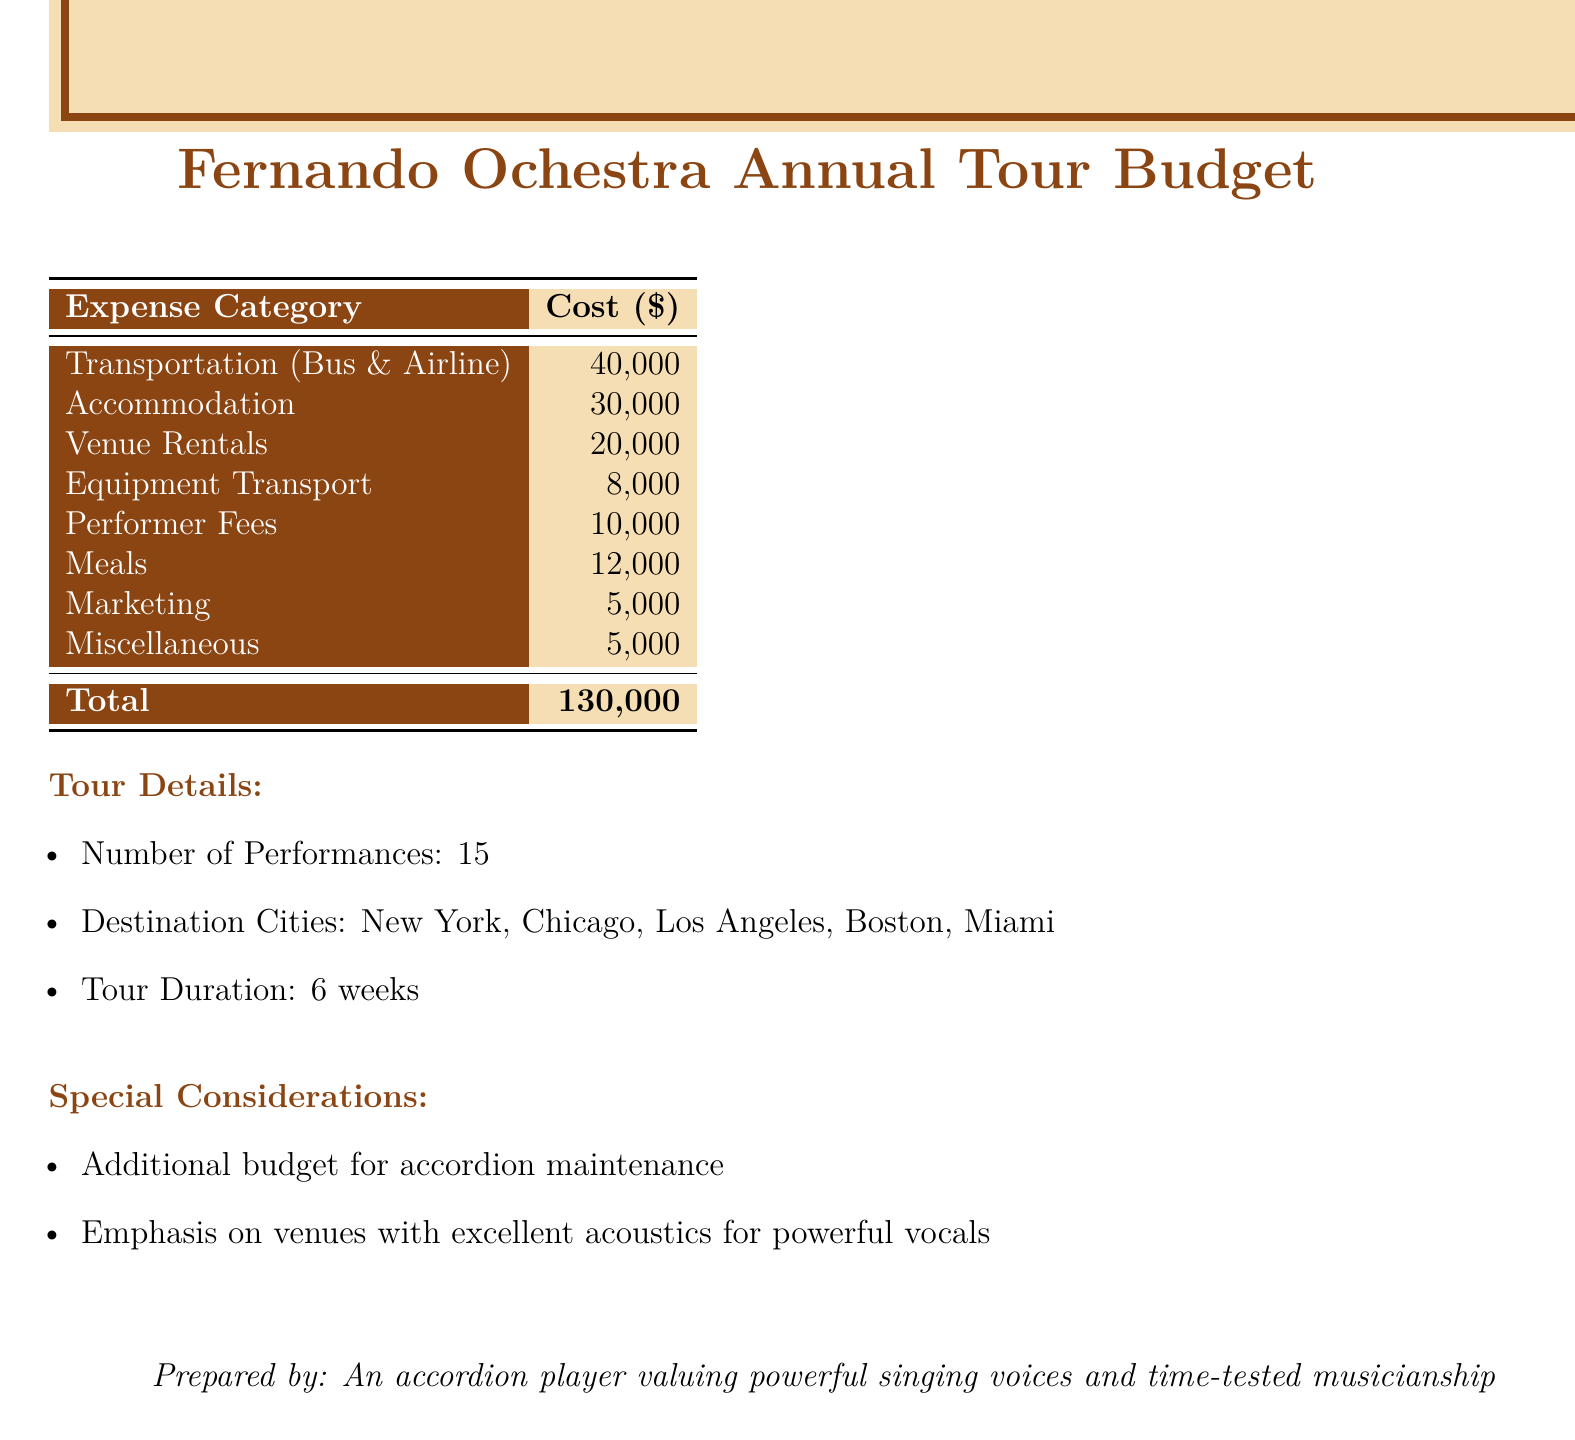What is the total cost of the budget? The total cost is found in the summary section of the document, listed as the total of all expenses, which is $130,000.
Answer: $130,000 How many destination cities are mentioned? The number of destination cities can be found in the tour details, where five cities are listed.
Answer: 5 What is the budget allocated for Marketing? The Marketing expense is clearly defined in the budget table, which shows that it amounts to $5,000.
Answer: $5,000 What is the total cost for Accommodation? The Accommodation cost is listed in the budget table, specifically noted as $30,000.
Answer: $30,000 How many performances are planned during the tour? The number of performances is indicated in the tour details section, stating there will be 15 performances.
Answer: 15 What is the duration of the tour? The duration of the tour is presented in the tour details, indicated as 6 weeks.
Answer: 6 weeks What is the proposed budget for performer fees? The performer fees amount is stated in the budget table, which designates it as $10,000.
Answer: $10,000 What special consideration is mentioned regarding venues? The special consideration indicates a preference for venues, emphasizing those with excellent acoustics for vocal performances.
Answer: Excellent acoustics for powerful vocals 